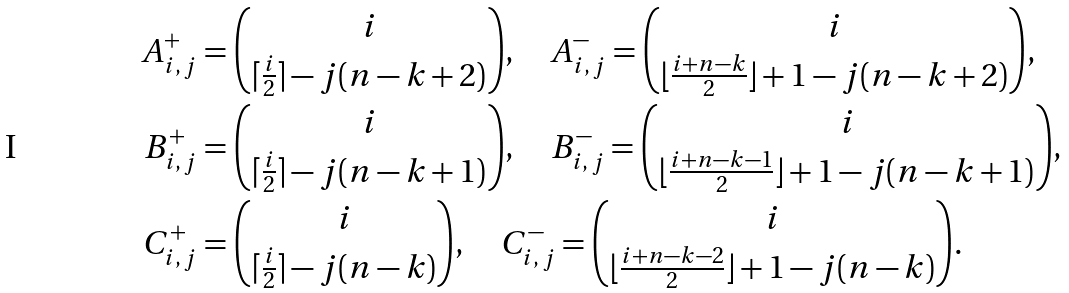Convert formula to latex. <formula><loc_0><loc_0><loc_500><loc_500>A ^ { + } _ { i , \, j } & = { i \choose \lceil \frac { i } { 2 } \rceil - j ( n - k + 2 ) } , \quad A ^ { - } _ { i , \, j } = { i \choose \lfloor \frac { i + n - k } { 2 } \rfloor + 1 - j ( n - k + 2 ) } , \\ B ^ { + } _ { i , \, j } & = { i \choose \lceil \frac { i } { 2 } \rceil - j ( n - k + 1 ) } , \quad B ^ { - } _ { i , \, j } = { i \choose \lfloor \frac { i + n - k - 1 } { 2 } \rfloor + 1 - j ( n - k + 1 ) } , \\ C ^ { + } _ { i , \, j } & = { i \choose \lceil \frac { i } { 2 } \rceil - j ( n - k ) } , \quad C ^ { - } _ { i , \, j } = { i \choose \lfloor \frac { i + n - k - 2 } { 2 } \rfloor + 1 - j ( n - k ) } .</formula> 